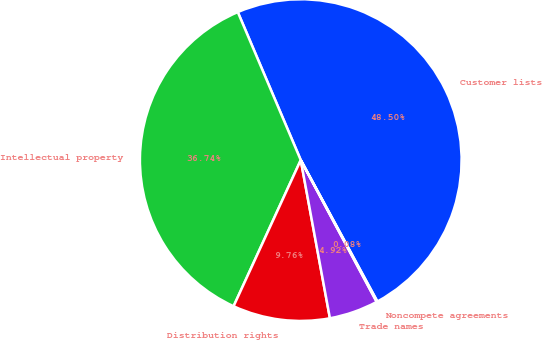<chart> <loc_0><loc_0><loc_500><loc_500><pie_chart><fcel>Customer lists<fcel>Intellectual property<fcel>Distribution rights<fcel>Trade names<fcel>Noncompete agreements<nl><fcel>48.5%<fcel>36.74%<fcel>9.76%<fcel>4.92%<fcel>0.08%<nl></chart> 